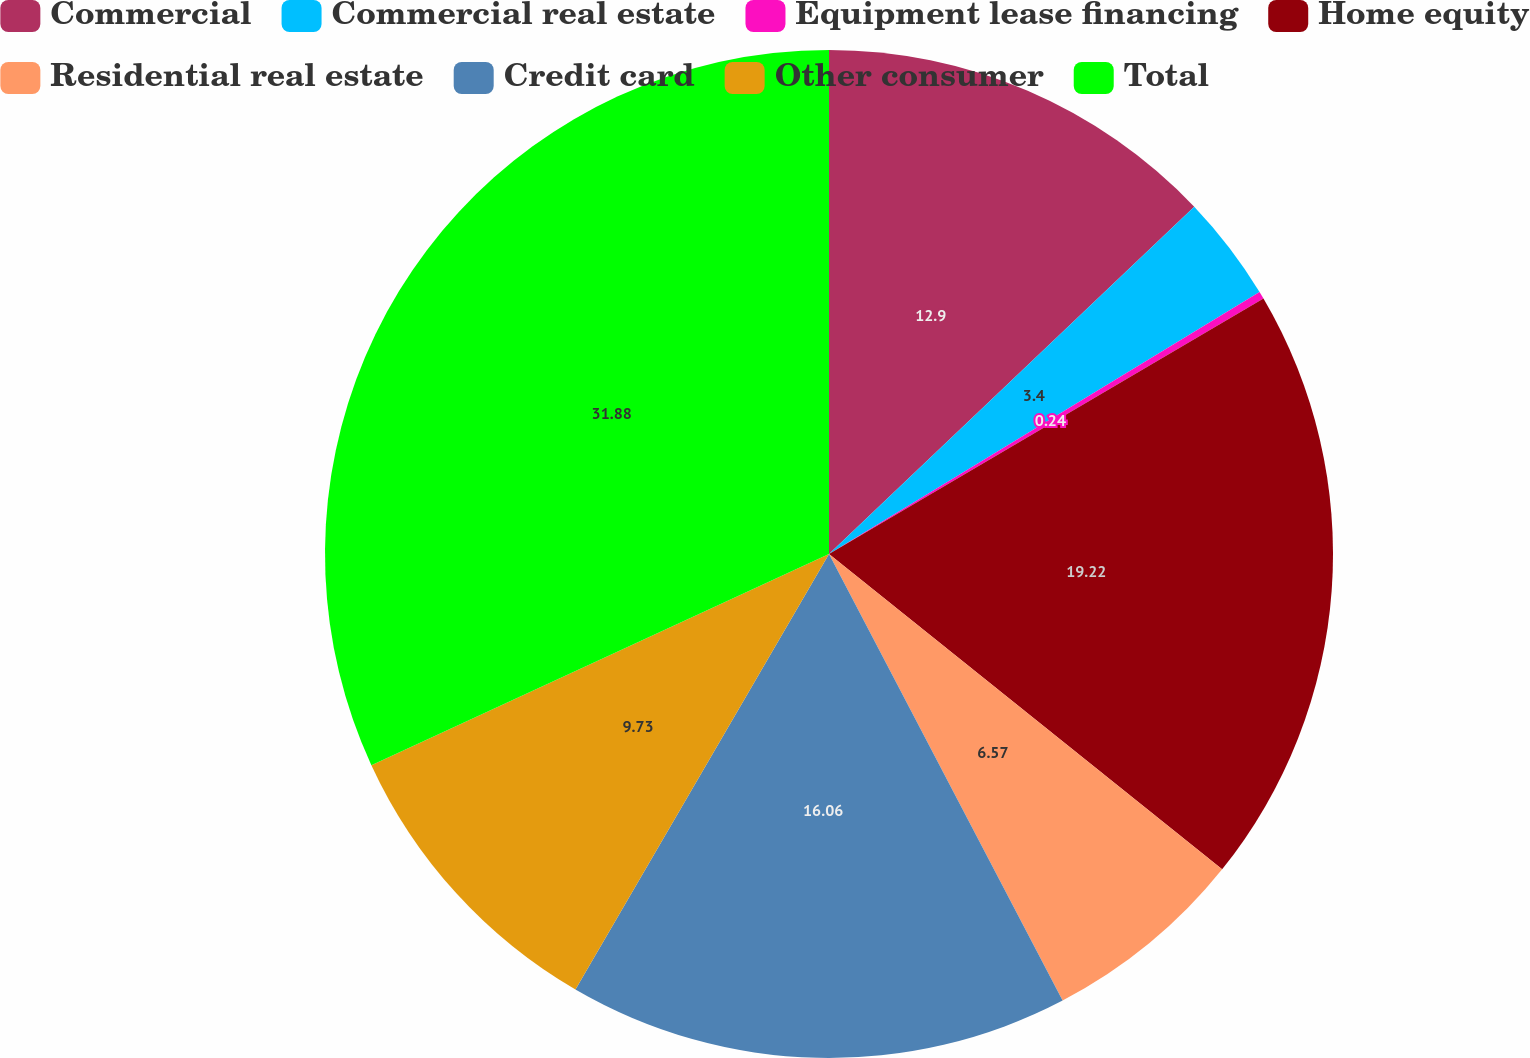Convert chart. <chart><loc_0><loc_0><loc_500><loc_500><pie_chart><fcel>Commercial<fcel>Commercial real estate<fcel>Equipment lease financing<fcel>Home equity<fcel>Residential real estate<fcel>Credit card<fcel>Other consumer<fcel>Total<nl><fcel>12.9%<fcel>3.4%<fcel>0.24%<fcel>19.22%<fcel>6.57%<fcel>16.06%<fcel>9.73%<fcel>31.88%<nl></chart> 